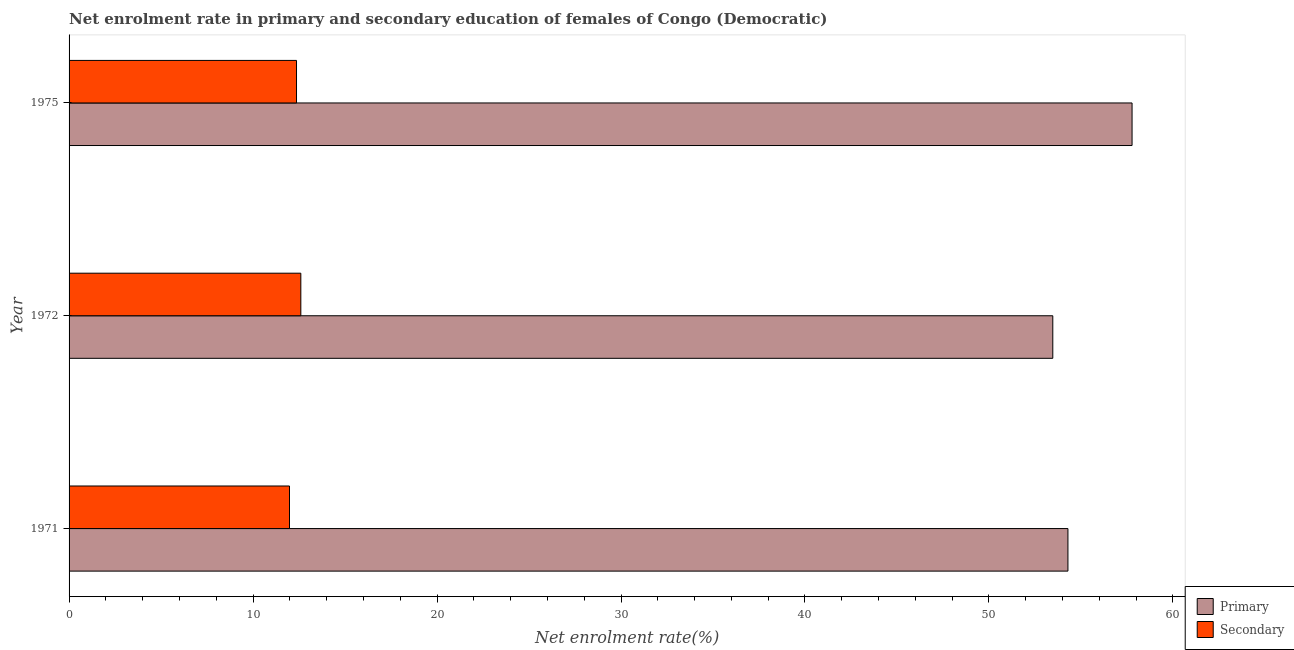How many different coloured bars are there?
Your answer should be very brief. 2. How many groups of bars are there?
Keep it short and to the point. 3. What is the label of the 1st group of bars from the top?
Your response must be concise. 1975. What is the enrollment rate in secondary education in 1971?
Your answer should be compact. 11.98. Across all years, what is the maximum enrollment rate in primary education?
Your answer should be compact. 57.78. Across all years, what is the minimum enrollment rate in primary education?
Your answer should be very brief. 53.47. What is the total enrollment rate in secondary education in the graph?
Keep it short and to the point. 36.94. What is the difference between the enrollment rate in primary education in 1971 and that in 1975?
Offer a terse response. -3.48. What is the difference between the enrollment rate in primary education in 1971 and the enrollment rate in secondary education in 1975?
Make the answer very short. 41.93. What is the average enrollment rate in primary education per year?
Provide a short and direct response. 55.18. In the year 1971, what is the difference between the enrollment rate in secondary education and enrollment rate in primary education?
Provide a short and direct response. -42.31. What is the ratio of the enrollment rate in secondary education in 1971 to that in 1972?
Offer a very short reply. 0.95. What is the difference between the highest and the second highest enrollment rate in primary education?
Ensure brevity in your answer.  3.48. What is the difference between the highest and the lowest enrollment rate in secondary education?
Make the answer very short. 0.62. In how many years, is the enrollment rate in primary education greater than the average enrollment rate in primary education taken over all years?
Your answer should be compact. 1. Is the sum of the enrollment rate in secondary education in 1971 and 1975 greater than the maximum enrollment rate in primary education across all years?
Keep it short and to the point. No. What does the 2nd bar from the top in 1971 represents?
Provide a succinct answer. Primary. What does the 2nd bar from the bottom in 1975 represents?
Your response must be concise. Secondary. How many years are there in the graph?
Your answer should be compact. 3. Does the graph contain any zero values?
Your answer should be very brief. No. Does the graph contain grids?
Provide a short and direct response. No. Where does the legend appear in the graph?
Provide a succinct answer. Bottom right. How many legend labels are there?
Offer a very short reply. 2. How are the legend labels stacked?
Provide a short and direct response. Vertical. What is the title of the graph?
Make the answer very short. Net enrolment rate in primary and secondary education of females of Congo (Democratic). Does "Net savings(excluding particulate emission damage)" appear as one of the legend labels in the graph?
Give a very brief answer. No. What is the label or title of the X-axis?
Provide a short and direct response. Net enrolment rate(%). What is the Net enrolment rate(%) of Primary in 1971?
Your answer should be very brief. 54.29. What is the Net enrolment rate(%) of Secondary in 1971?
Your answer should be compact. 11.98. What is the Net enrolment rate(%) in Primary in 1972?
Offer a terse response. 53.47. What is the Net enrolment rate(%) in Secondary in 1972?
Ensure brevity in your answer.  12.6. What is the Net enrolment rate(%) of Primary in 1975?
Make the answer very short. 57.78. What is the Net enrolment rate(%) in Secondary in 1975?
Provide a succinct answer. 12.36. Across all years, what is the maximum Net enrolment rate(%) in Primary?
Offer a very short reply. 57.78. Across all years, what is the maximum Net enrolment rate(%) in Secondary?
Offer a terse response. 12.6. Across all years, what is the minimum Net enrolment rate(%) of Primary?
Offer a very short reply. 53.47. Across all years, what is the minimum Net enrolment rate(%) of Secondary?
Make the answer very short. 11.98. What is the total Net enrolment rate(%) in Primary in the graph?
Ensure brevity in your answer.  165.54. What is the total Net enrolment rate(%) in Secondary in the graph?
Keep it short and to the point. 36.94. What is the difference between the Net enrolment rate(%) in Primary in 1971 and that in 1972?
Your answer should be compact. 0.82. What is the difference between the Net enrolment rate(%) in Secondary in 1971 and that in 1972?
Keep it short and to the point. -0.62. What is the difference between the Net enrolment rate(%) in Primary in 1971 and that in 1975?
Your answer should be very brief. -3.49. What is the difference between the Net enrolment rate(%) in Secondary in 1971 and that in 1975?
Provide a succinct answer. -0.38. What is the difference between the Net enrolment rate(%) in Primary in 1972 and that in 1975?
Provide a succinct answer. -4.31. What is the difference between the Net enrolment rate(%) in Secondary in 1972 and that in 1975?
Give a very brief answer. 0.23. What is the difference between the Net enrolment rate(%) of Primary in 1971 and the Net enrolment rate(%) of Secondary in 1972?
Your answer should be very brief. 41.7. What is the difference between the Net enrolment rate(%) of Primary in 1971 and the Net enrolment rate(%) of Secondary in 1975?
Offer a very short reply. 41.93. What is the difference between the Net enrolment rate(%) of Primary in 1972 and the Net enrolment rate(%) of Secondary in 1975?
Your response must be concise. 41.11. What is the average Net enrolment rate(%) of Primary per year?
Offer a terse response. 55.18. What is the average Net enrolment rate(%) in Secondary per year?
Offer a terse response. 12.31. In the year 1971, what is the difference between the Net enrolment rate(%) in Primary and Net enrolment rate(%) in Secondary?
Keep it short and to the point. 42.31. In the year 1972, what is the difference between the Net enrolment rate(%) in Primary and Net enrolment rate(%) in Secondary?
Give a very brief answer. 40.87. In the year 1975, what is the difference between the Net enrolment rate(%) in Primary and Net enrolment rate(%) in Secondary?
Offer a terse response. 45.42. What is the ratio of the Net enrolment rate(%) of Primary in 1971 to that in 1972?
Provide a short and direct response. 1.02. What is the ratio of the Net enrolment rate(%) of Secondary in 1971 to that in 1972?
Make the answer very short. 0.95. What is the ratio of the Net enrolment rate(%) in Primary in 1971 to that in 1975?
Provide a short and direct response. 0.94. What is the ratio of the Net enrolment rate(%) of Secondary in 1971 to that in 1975?
Ensure brevity in your answer.  0.97. What is the ratio of the Net enrolment rate(%) in Primary in 1972 to that in 1975?
Provide a short and direct response. 0.93. What is the difference between the highest and the second highest Net enrolment rate(%) of Primary?
Keep it short and to the point. 3.49. What is the difference between the highest and the second highest Net enrolment rate(%) of Secondary?
Your answer should be very brief. 0.23. What is the difference between the highest and the lowest Net enrolment rate(%) in Primary?
Ensure brevity in your answer.  4.31. What is the difference between the highest and the lowest Net enrolment rate(%) of Secondary?
Provide a succinct answer. 0.62. 